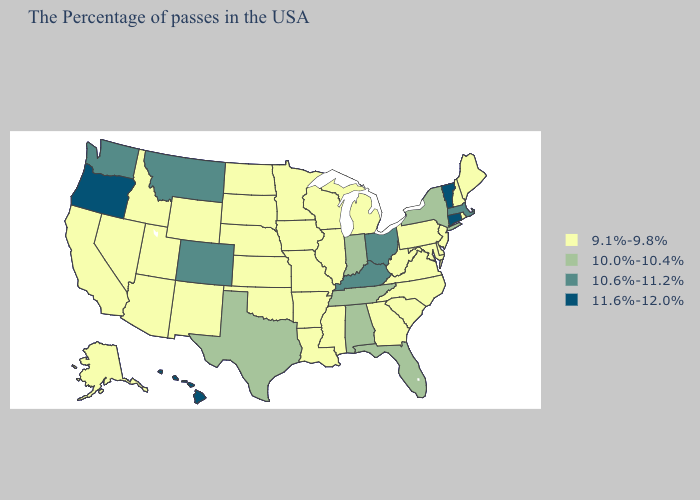What is the lowest value in the USA?
Write a very short answer. 9.1%-9.8%. Does New Hampshire have the highest value in the Northeast?
Be succinct. No. Is the legend a continuous bar?
Give a very brief answer. No. Does New York have a lower value than Georgia?
Answer briefly. No. Does Kansas have the lowest value in the MidWest?
Concise answer only. Yes. How many symbols are there in the legend?
Quick response, please. 4. What is the value of Hawaii?
Quick response, please. 11.6%-12.0%. Which states have the lowest value in the USA?
Give a very brief answer. Maine, Rhode Island, New Hampshire, New Jersey, Delaware, Maryland, Pennsylvania, Virginia, North Carolina, South Carolina, West Virginia, Georgia, Michigan, Wisconsin, Illinois, Mississippi, Louisiana, Missouri, Arkansas, Minnesota, Iowa, Kansas, Nebraska, Oklahoma, South Dakota, North Dakota, Wyoming, New Mexico, Utah, Arizona, Idaho, Nevada, California, Alaska. Does Vermont have the highest value in the USA?
Short answer required. Yes. What is the value of Oklahoma?
Short answer required. 9.1%-9.8%. Is the legend a continuous bar?
Concise answer only. No. Name the states that have a value in the range 10.0%-10.4%?
Write a very short answer. New York, Florida, Indiana, Alabama, Tennessee, Texas. Does the first symbol in the legend represent the smallest category?
Quick response, please. Yes. Does the first symbol in the legend represent the smallest category?
Keep it brief. Yes. 